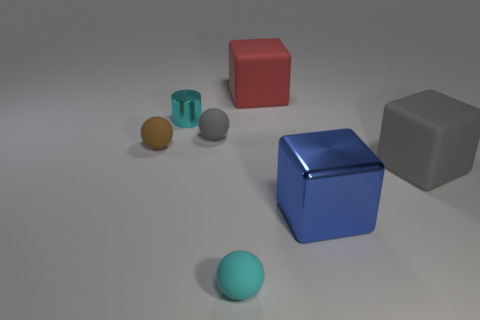Subtract all gray rubber balls. How many balls are left? 2 Add 2 cyan metal cubes. How many objects exist? 9 Subtract all cyan spheres. How many spheres are left? 2 Subtract all balls. How many objects are left? 4 Subtract all small red metal objects. Subtract all gray matte objects. How many objects are left? 5 Add 3 small gray balls. How many small gray balls are left? 4 Add 1 large cyan balls. How many large cyan balls exist? 1 Subtract 1 brown balls. How many objects are left? 6 Subtract 2 balls. How many balls are left? 1 Subtract all brown spheres. Subtract all red cylinders. How many spheres are left? 2 